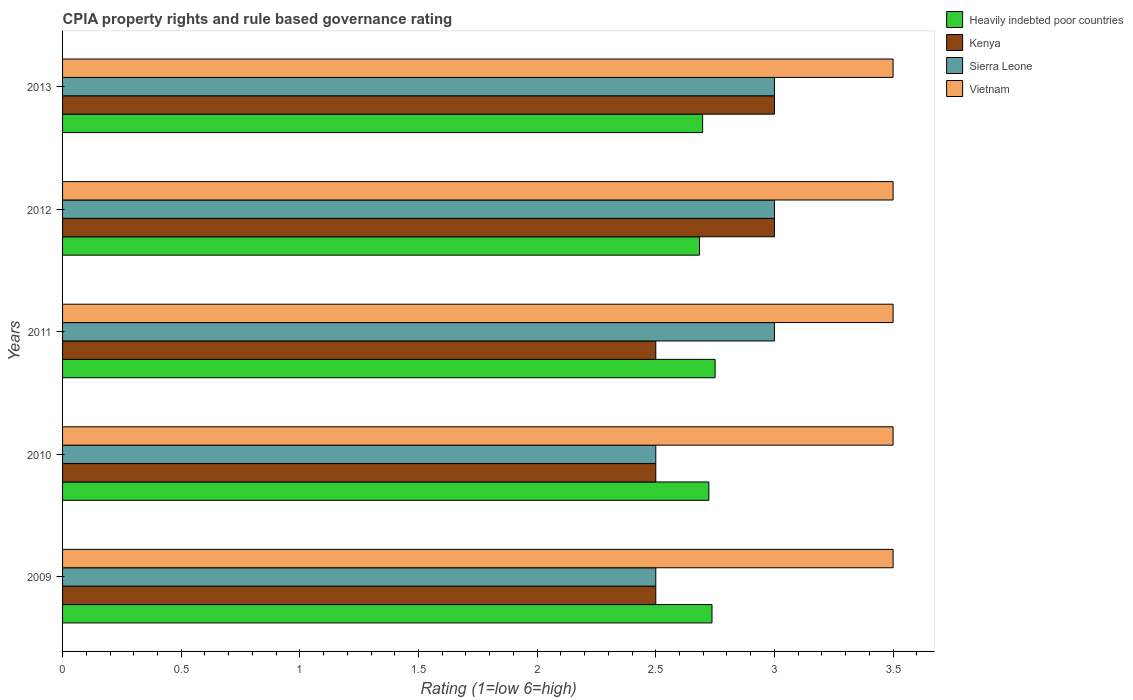How many different coloured bars are there?
Provide a short and direct response. 4. How many groups of bars are there?
Make the answer very short. 5. In how many cases, is the number of bars for a given year not equal to the number of legend labels?
Your answer should be very brief. 0. What is the CPIA rating in Sierra Leone in 2012?
Provide a short and direct response. 3. Across all years, what is the maximum CPIA rating in Vietnam?
Ensure brevity in your answer.  3.5. Across all years, what is the minimum CPIA rating in Kenya?
Provide a succinct answer. 2.5. In which year was the CPIA rating in Heavily indebted poor countries maximum?
Provide a succinct answer. 2011. In which year was the CPIA rating in Vietnam minimum?
Your answer should be compact. 2009. What is the difference between the CPIA rating in Heavily indebted poor countries in 2010 and that in 2011?
Give a very brief answer. -0.03. What is the difference between the CPIA rating in Kenya in 2011 and the CPIA rating in Heavily indebted poor countries in 2012?
Offer a very short reply. -0.18. What is the average CPIA rating in Heavily indebted poor countries per year?
Your response must be concise. 2.72. In the year 2011, what is the difference between the CPIA rating in Heavily indebted poor countries and CPIA rating in Vietnam?
Offer a very short reply. -0.75. What is the ratio of the CPIA rating in Heavily indebted poor countries in 2012 to that in 2013?
Provide a succinct answer. 1. Is the CPIA rating in Vietnam in 2009 less than that in 2013?
Your response must be concise. No. Is the sum of the CPIA rating in Sierra Leone in 2009 and 2011 greater than the maximum CPIA rating in Kenya across all years?
Offer a very short reply. Yes. Is it the case that in every year, the sum of the CPIA rating in Heavily indebted poor countries and CPIA rating in Vietnam is greater than the sum of CPIA rating in Sierra Leone and CPIA rating in Kenya?
Give a very brief answer. No. What does the 4th bar from the top in 2012 represents?
Provide a short and direct response. Heavily indebted poor countries. What does the 4th bar from the bottom in 2010 represents?
Provide a short and direct response. Vietnam. Is it the case that in every year, the sum of the CPIA rating in Sierra Leone and CPIA rating in Kenya is greater than the CPIA rating in Heavily indebted poor countries?
Your answer should be very brief. Yes. Are all the bars in the graph horizontal?
Offer a terse response. Yes. How many years are there in the graph?
Give a very brief answer. 5. What is the difference between two consecutive major ticks on the X-axis?
Ensure brevity in your answer.  0.5. Are the values on the major ticks of X-axis written in scientific E-notation?
Ensure brevity in your answer.  No. Does the graph contain any zero values?
Provide a short and direct response. No. How many legend labels are there?
Give a very brief answer. 4. What is the title of the graph?
Give a very brief answer. CPIA property rights and rule based governance rating. What is the label or title of the X-axis?
Your answer should be compact. Rating (1=low 6=high). What is the Rating (1=low 6=high) of Heavily indebted poor countries in 2009?
Your response must be concise. 2.74. What is the Rating (1=low 6=high) in Kenya in 2009?
Your answer should be compact. 2.5. What is the Rating (1=low 6=high) in Sierra Leone in 2009?
Offer a very short reply. 2.5. What is the Rating (1=low 6=high) of Vietnam in 2009?
Offer a very short reply. 3.5. What is the Rating (1=low 6=high) in Heavily indebted poor countries in 2010?
Provide a short and direct response. 2.72. What is the Rating (1=low 6=high) in Kenya in 2010?
Ensure brevity in your answer.  2.5. What is the Rating (1=low 6=high) in Sierra Leone in 2010?
Ensure brevity in your answer.  2.5. What is the Rating (1=low 6=high) of Vietnam in 2010?
Make the answer very short. 3.5. What is the Rating (1=low 6=high) in Heavily indebted poor countries in 2011?
Offer a terse response. 2.75. What is the Rating (1=low 6=high) in Kenya in 2011?
Make the answer very short. 2.5. What is the Rating (1=low 6=high) in Heavily indebted poor countries in 2012?
Offer a terse response. 2.68. What is the Rating (1=low 6=high) of Heavily indebted poor countries in 2013?
Keep it short and to the point. 2.7. What is the Rating (1=low 6=high) of Kenya in 2013?
Your response must be concise. 3. What is the Rating (1=low 6=high) of Sierra Leone in 2013?
Your answer should be compact. 3. What is the Rating (1=low 6=high) in Vietnam in 2013?
Ensure brevity in your answer.  3.5. Across all years, what is the maximum Rating (1=low 6=high) of Heavily indebted poor countries?
Your answer should be compact. 2.75. Across all years, what is the maximum Rating (1=low 6=high) in Kenya?
Give a very brief answer. 3. Across all years, what is the maximum Rating (1=low 6=high) of Sierra Leone?
Your answer should be compact. 3. Across all years, what is the minimum Rating (1=low 6=high) of Heavily indebted poor countries?
Provide a short and direct response. 2.68. What is the total Rating (1=low 6=high) in Heavily indebted poor countries in the graph?
Make the answer very short. 13.59. What is the total Rating (1=low 6=high) in Kenya in the graph?
Offer a very short reply. 13.5. What is the difference between the Rating (1=low 6=high) of Heavily indebted poor countries in 2009 and that in 2010?
Provide a short and direct response. 0.01. What is the difference between the Rating (1=low 6=high) of Vietnam in 2009 and that in 2010?
Offer a very short reply. 0. What is the difference between the Rating (1=low 6=high) of Heavily indebted poor countries in 2009 and that in 2011?
Make the answer very short. -0.01. What is the difference between the Rating (1=low 6=high) in Vietnam in 2009 and that in 2011?
Provide a succinct answer. 0. What is the difference between the Rating (1=low 6=high) of Heavily indebted poor countries in 2009 and that in 2012?
Your response must be concise. 0.05. What is the difference between the Rating (1=low 6=high) in Heavily indebted poor countries in 2009 and that in 2013?
Provide a short and direct response. 0.04. What is the difference between the Rating (1=low 6=high) in Kenya in 2009 and that in 2013?
Your answer should be very brief. -0.5. What is the difference between the Rating (1=low 6=high) in Heavily indebted poor countries in 2010 and that in 2011?
Your answer should be compact. -0.03. What is the difference between the Rating (1=low 6=high) of Sierra Leone in 2010 and that in 2011?
Make the answer very short. -0.5. What is the difference between the Rating (1=low 6=high) in Vietnam in 2010 and that in 2011?
Offer a very short reply. 0. What is the difference between the Rating (1=low 6=high) of Heavily indebted poor countries in 2010 and that in 2012?
Provide a short and direct response. 0.04. What is the difference between the Rating (1=low 6=high) of Vietnam in 2010 and that in 2012?
Give a very brief answer. 0. What is the difference between the Rating (1=low 6=high) in Heavily indebted poor countries in 2010 and that in 2013?
Your answer should be compact. 0.03. What is the difference between the Rating (1=low 6=high) in Kenya in 2010 and that in 2013?
Your response must be concise. -0.5. What is the difference between the Rating (1=low 6=high) of Heavily indebted poor countries in 2011 and that in 2012?
Your answer should be compact. 0.07. What is the difference between the Rating (1=low 6=high) in Sierra Leone in 2011 and that in 2012?
Provide a succinct answer. 0. What is the difference between the Rating (1=low 6=high) of Heavily indebted poor countries in 2011 and that in 2013?
Offer a terse response. 0.05. What is the difference between the Rating (1=low 6=high) in Vietnam in 2011 and that in 2013?
Offer a terse response. 0. What is the difference between the Rating (1=low 6=high) of Heavily indebted poor countries in 2012 and that in 2013?
Keep it short and to the point. -0.01. What is the difference between the Rating (1=low 6=high) of Kenya in 2012 and that in 2013?
Make the answer very short. 0. What is the difference between the Rating (1=low 6=high) in Sierra Leone in 2012 and that in 2013?
Keep it short and to the point. 0. What is the difference between the Rating (1=low 6=high) of Heavily indebted poor countries in 2009 and the Rating (1=low 6=high) of Kenya in 2010?
Give a very brief answer. 0.24. What is the difference between the Rating (1=low 6=high) in Heavily indebted poor countries in 2009 and the Rating (1=low 6=high) in Sierra Leone in 2010?
Provide a succinct answer. 0.24. What is the difference between the Rating (1=low 6=high) in Heavily indebted poor countries in 2009 and the Rating (1=low 6=high) in Vietnam in 2010?
Give a very brief answer. -0.76. What is the difference between the Rating (1=low 6=high) of Kenya in 2009 and the Rating (1=low 6=high) of Sierra Leone in 2010?
Offer a very short reply. 0. What is the difference between the Rating (1=low 6=high) of Kenya in 2009 and the Rating (1=low 6=high) of Vietnam in 2010?
Provide a succinct answer. -1. What is the difference between the Rating (1=low 6=high) in Heavily indebted poor countries in 2009 and the Rating (1=low 6=high) in Kenya in 2011?
Ensure brevity in your answer.  0.24. What is the difference between the Rating (1=low 6=high) of Heavily indebted poor countries in 2009 and the Rating (1=low 6=high) of Sierra Leone in 2011?
Keep it short and to the point. -0.26. What is the difference between the Rating (1=low 6=high) of Heavily indebted poor countries in 2009 and the Rating (1=low 6=high) of Vietnam in 2011?
Your answer should be compact. -0.76. What is the difference between the Rating (1=low 6=high) of Kenya in 2009 and the Rating (1=low 6=high) of Vietnam in 2011?
Provide a succinct answer. -1. What is the difference between the Rating (1=low 6=high) in Heavily indebted poor countries in 2009 and the Rating (1=low 6=high) in Kenya in 2012?
Keep it short and to the point. -0.26. What is the difference between the Rating (1=low 6=high) of Heavily indebted poor countries in 2009 and the Rating (1=low 6=high) of Sierra Leone in 2012?
Your answer should be compact. -0.26. What is the difference between the Rating (1=low 6=high) in Heavily indebted poor countries in 2009 and the Rating (1=low 6=high) in Vietnam in 2012?
Give a very brief answer. -0.76. What is the difference between the Rating (1=low 6=high) of Sierra Leone in 2009 and the Rating (1=low 6=high) of Vietnam in 2012?
Offer a very short reply. -1. What is the difference between the Rating (1=low 6=high) in Heavily indebted poor countries in 2009 and the Rating (1=low 6=high) in Kenya in 2013?
Provide a succinct answer. -0.26. What is the difference between the Rating (1=low 6=high) of Heavily indebted poor countries in 2009 and the Rating (1=low 6=high) of Sierra Leone in 2013?
Your answer should be very brief. -0.26. What is the difference between the Rating (1=low 6=high) in Heavily indebted poor countries in 2009 and the Rating (1=low 6=high) in Vietnam in 2013?
Give a very brief answer. -0.76. What is the difference between the Rating (1=low 6=high) of Heavily indebted poor countries in 2010 and the Rating (1=low 6=high) of Kenya in 2011?
Keep it short and to the point. 0.22. What is the difference between the Rating (1=low 6=high) in Heavily indebted poor countries in 2010 and the Rating (1=low 6=high) in Sierra Leone in 2011?
Offer a very short reply. -0.28. What is the difference between the Rating (1=low 6=high) of Heavily indebted poor countries in 2010 and the Rating (1=low 6=high) of Vietnam in 2011?
Keep it short and to the point. -0.78. What is the difference between the Rating (1=low 6=high) in Heavily indebted poor countries in 2010 and the Rating (1=low 6=high) in Kenya in 2012?
Make the answer very short. -0.28. What is the difference between the Rating (1=low 6=high) of Heavily indebted poor countries in 2010 and the Rating (1=low 6=high) of Sierra Leone in 2012?
Keep it short and to the point. -0.28. What is the difference between the Rating (1=low 6=high) of Heavily indebted poor countries in 2010 and the Rating (1=low 6=high) of Vietnam in 2012?
Offer a terse response. -0.78. What is the difference between the Rating (1=low 6=high) of Kenya in 2010 and the Rating (1=low 6=high) of Sierra Leone in 2012?
Offer a very short reply. -0.5. What is the difference between the Rating (1=low 6=high) of Heavily indebted poor countries in 2010 and the Rating (1=low 6=high) of Kenya in 2013?
Your answer should be very brief. -0.28. What is the difference between the Rating (1=low 6=high) of Heavily indebted poor countries in 2010 and the Rating (1=low 6=high) of Sierra Leone in 2013?
Make the answer very short. -0.28. What is the difference between the Rating (1=low 6=high) of Heavily indebted poor countries in 2010 and the Rating (1=low 6=high) of Vietnam in 2013?
Provide a succinct answer. -0.78. What is the difference between the Rating (1=low 6=high) of Kenya in 2010 and the Rating (1=low 6=high) of Sierra Leone in 2013?
Keep it short and to the point. -0.5. What is the difference between the Rating (1=low 6=high) of Kenya in 2010 and the Rating (1=low 6=high) of Vietnam in 2013?
Keep it short and to the point. -1. What is the difference between the Rating (1=low 6=high) of Heavily indebted poor countries in 2011 and the Rating (1=low 6=high) of Kenya in 2012?
Ensure brevity in your answer.  -0.25. What is the difference between the Rating (1=low 6=high) in Heavily indebted poor countries in 2011 and the Rating (1=low 6=high) in Sierra Leone in 2012?
Make the answer very short. -0.25. What is the difference between the Rating (1=low 6=high) of Heavily indebted poor countries in 2011 and the Rating (1=low 6=high) of Vietnam in 2012?
Your response must be concise. -0.75. What is the difference between the Rating (1=low 6=high) in Kenya in 2011 and the Rating (1=low 6=high) in Sierra Leone in 2012?
Make the answer very short. -0.5. What is the difference between the Rating (1=low 6=high) in Kenya in 2011 and the Rating (1=low 6=high) in Vietnam in 2012?
Make the answer very short. -1. What is the difference between the Rating (1=low 6=high) in Heavily indebted poor countries in 2011 and the Rating (1=low 6=high) in Vietnam in 2013?
Provide a short and direct response. -0.75. What is the difference between the Rating (1=low 6=high) in Heavily indebted poor countries in 2012 and the Rating (1=low 6=high) in Kenya in 2013?
Ensure brevity in your answer.  -0.32. What is the difference between the Rating (1=low 6=high) of Heavily indebted poor countries in 2012 and the Rating (1=low 6=high) of Sierra Leone in 2013?
Offer a very short reply. -0.32. What is the difference between the Rating (1=low 6=high) in Heavily indebted poor countries in 2012 and the Rating (1=low 6=high) in Vietnam in 2013?
Offer a very short reply. -0.82. What is the difference between the Rating (1=low 6=high) of Kenya in 2012 and the Rating (1=low 6=high) of Sierra Leone in 2013?
Give a very brief answer. 0. What is the average Rating (1=low 6=high) in Heavily indebted poor countries per year?
Provide a short and direct response. 2.72. What is the average Rating (1=low 6=high) of Sierra Leone per year?
Your response must be concise. 2.8. What is the average Rating (1=low 6=high) of Vietnam per year?
Provide a succinct answer. 3.5. In the year 2009, what is the difference between the Rating (1=low 6=high) in Heavily indebted poor countries and Rating (1=low 6=high) in Kenya?
Offer a terse response. 0.24. In the year 2009, what is the difference between the Rating (1=low 6=high) of Heavily indebted poor countries and Rating (1=low 6=high) of Sierra Leone?
Your response must be concise. 0.24. In the year 2009, what is the difference between the Rating (1=low 6=high) in Heavily indebted poor countries and Rating (1=low 6=high) in Vietnam?
Your answer should be very brief. -0.76. In the year 2009, what is the difference between the Rating (1=low 6=high) in Kenya and Rating (1=low 6=high) in Vietnam?
Make the answer very short. -1. In the year 2009, what is the difference between the Rating (1=low 6=high) of Sierra Leone and Rating (1=low 6=high) of Vietnam?
Offer a very short reply. -1. In the year 2010, what is the difference between the Rating (1=low 6=high) of Heavily indebted poor countries and Rating (1=low 6=high) of Kenya?
Your response must be concise. 0.22. In the year 2010, what is the difference between the Rating (1=low 6=high) in Heavily indebted poor countries and Rating (1=low 6=high) in Sierra Leone?
Your answer should be compact. 0.22. In the year 2010, what is the difference between the Rating (1=low 6=high) in Heavily indebted poor countries and Rating (1=low 6=high) in Vietnam?
Provide a succinct answer. -0.78. In the year 2010, what is the difference between the Rating (1=low 6=high) in Kenya and Rating (1=low 6=high) in Vietnam?
Give a very brief answer. -1. In the year 2011, what is the difference between the Rating (1=low 6=high) of Heavily indebted poor countries and Rating (1=low 6=high) of Kenya?
Give a very brief answer. 0.25. In the year 2011, what is the difference between the Rating (1=low 6=high) in Heavily indebted poor countries and Rating (1=low 6=high) in Sierra Leone?
Make the answer very short. -0.25. In the year 2011, what is the difference between the Rating (1=low 6=high) in Heavily indebted poor countries and Rating (1=low 6=high) in Vietnam?
Ensure brevity in your answer.  -0.75. In the year 2011, what is the difference between the Rating (1=low 6=high) in Kenya and Rating (1=low 6=high) in Sierra Leone?
Your answer should be very brief. -0.5. In the year 2011, what is the difference between the Rating (1=low 6=high) of Kenya and Rating (1=low 6=high) of Vietnam?
Your response must be concise. -1. In the year 2011, what is the difference between the Rating (1=low 6=high) of Sierra Leone and Rating (1=low 6=high) of Vietnam?
Give a very brief answer. -0.5. In the year 2012, what is the difference between the Rating (1=low 6=high) in Heavily indebted poor countries and Rating (1=low 6=high) in Kenya?
Offer a very short reply. -0.32. In the year 2012, what is the difference between the Rating (1=low 6=high) of Heavily indebted poor countries and Rating (1=low 6=high) of Sierra Leone?
Your answer should be compact. -0.32. In the year 2012, what is the difference between the Rating (1=low 6=high) of Heavily indebted poor countries and Rating (1=low 6=high) of Vietnam?
Give a very brief answer. -0.82. In the year 2012, what is the difference between the Rating (1=low 6=high) in Kenya and Rating (1=low 6=high) in Sierra Leone?
Keep it short and to the point. 0. In the year 2013, what is the difference between the Rating (1=low 6=high) of Heavily indebted poor countries and Rating (1=low 6=high) of Kenya?
Ensure brevity in your answer.  -0.3. In the year 2013, what is the difference between the Rating (1=low 6=high) of Heavily indebted poor countries and Rating (1=low 6=high) of Sierra Leone?
Provide a succinct answer. -0.3. In the year 2013, what is the difference between the Rating (1=low 6=high) of Heavily indebted poor countries and Rating (1=low 6=high) of Vietnam?
Your response must be concise. -0.8. In the year 2013, what is the difference between the Rating (1=low 6=high) in Kenya and Rating (1=low 6=high) in Sierra Leone?
Offer a very short reply. 0. What is the ratio of the Rating (1=low 6=high) of Heavily indebted poor countries in 2009 to that in 2010?
Make the answer very short. 1. What is the ratio of the Rating (1=low 6=high) of Heavily indebted poor countries in 2009 to that in 2011?
Offer a terse response. 1. What is the ratio of the Rating (1=low 6=high) in Kenya in 2009 to that in 2011?
Your answer should be very brief. 1. What is the ratio of the Rating (1=low 6=high) in Sierra Leone in 2009 to that in 2011?
Give a very brief answer. 0.83. What is the ratio of the Rating (1=low 6=high) in Heavily indebted poor countries in 2009 to that in 2012?
Make the answer very short. 1.02. What is the ratio of the Rating (1=low 6=high) in Kenya in 2009 to that in 2012?
Offer a terse response. 0.83. What is the ratio of the Rating (1=low 6=high) of Sierra Leone in 2009 to that in 2012?
Provide a succinct answer. 0.83. What is the ratio of the Rating (1=low 6=high) in Vietnam in 2009 to that in 2012?
Your answer should be very brief. 1. What is the ratio of the Rating (1=low 6=high) in Heavily indebted poor countries in 2009 to that in 2013?
Ensure brevity in your answer.  1.01. What is the ratio of the Rating (1=low 6=high) of Sierra Leone in 2009 to that in 2013?
Make the answer very short. 0.83. What is the ratio of the Rating (1=low 6=high) of Vietnam in 2009 to that in 2013?
Offer a terse response. 1. What is the ratio of the Rating (1=low 6=high) in Heavily indebted poor countries in 2010 to that in 2011?
Keep it short and to the point. 0.99. What is the ratio of the Rating (1=low 6=high) of Kenya in 2010 to that in 2011?
Your answer should be very brief. 1. What is the ratio of the Rating (1=low 6=high) of Sierra Leone in 2010 to that in 2011?
Your answer should be very brief. 0.83. What is the ratio of the Rating (1=low 6=high) in Vietnam in 2010 to that in 2011?
Make the answer very short. 1. What is the ratio of the Rating (1=low 6=high) of Heavily indebted poor countries in 2010 to that in 2012?
Make the answer very short. 1.01. What is the ratio of the Rating (1=low 6=high) of Heavily indebted poor countries in 2010 to that in 2013?
Provide a short and direct response. 1.01. What is the ratio of the Rating (1=low 6=high) of Kenya in 2010 to that in 2013?
Your answer should be compact. 0.83. What is the ratio of the Rating (1=low 6=high) in Sierra Leone in 2010 to that in 2013?
Your answer should be compact. 0.83. What is the ratio of the Rating (1=low 6=high) of Heavily indebted poor countries in 2011 to that in 2012?
Offer a terse response. 1.02. What is the ratio of the Rating (1=low 6=high) of Sierra Leone in 2011 to that in 2012?
Offer a terse response. 1. What is the ratio of the Rating (1=low 6=high) in Vietnam in 2011 to that in 2012?
Your answer should be compact. 1. What is the ratio of the Rating (1=low 6=high) of Heavily indebted poor countries in 2011 to that in 2013?
Offer a very short reply. 1.02. What is the ratio of the Rating (1=low 6=high) in Vietnam in 2011 to that in 2013?
Provide a succinct answer. 1. What is the difference between the highest and the second highest Rating (1=low 6=high) of Heavily indebted poor countries?
Provide a short and direct response. 0.01. What is the difference between the highest and the second highest Rating (1=low 6=high) in Sierra Leone?
Your answer should be compact. 0. What is the difference between the highest and the lowest Rating (1=low 6=high) in Heavily indebted poor countries?
Give a very brief answer. 0.07. What is the difference between the highest and the lowest Rating (1=low 6=high) of Kenya?
Your response must be concise. 0.5. 